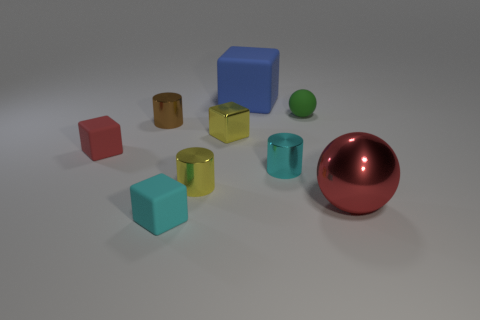Subtract all yellow shiny blocks. How many blocks are left? 3 Subtract all blocks. How many objects are left? 5 Subtract all cyan blocks. How many blocks are left? 3 Subtract 2 cylinders. How many cylinders are left? 1 Subtract all green cubes. Subtract all gray cylinders. How many cubes are left? 4 Subtract all red balls. How many red cubes are left? 1 Subtract all tiny red blocks. Subtract all yellow things. How many objects are left? 6 Add 9 small spheres. How many small spheres are left? 10 Add 8 large blue matte cubes. How many large blue matte cubes exist? 9 Subtract 0 brown balls. How many objects are left? 9 